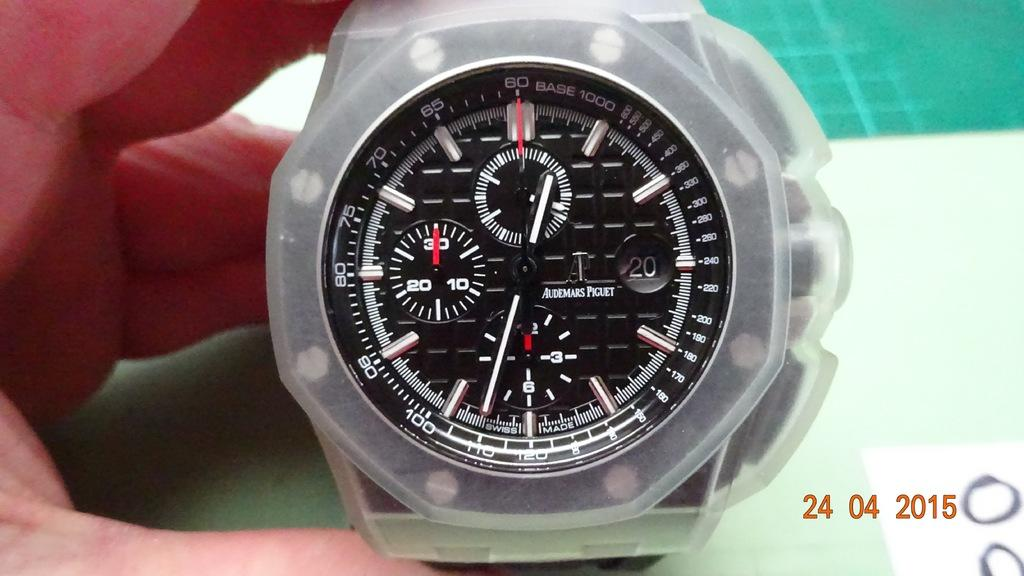<image>
Write a terse but informative summary of the picture. A watch with several dials on the face and the daet 24.04.2015. 